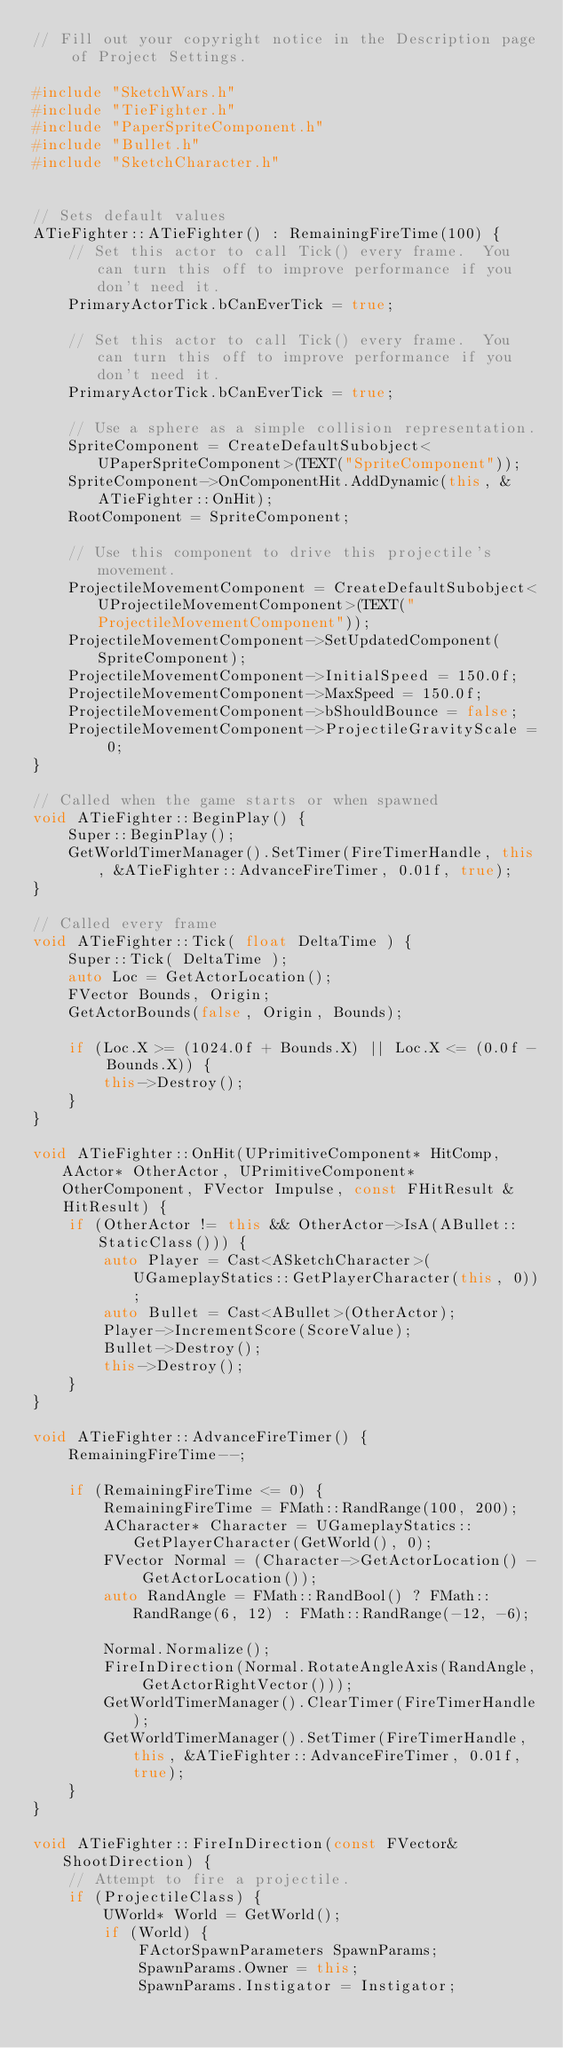<code> <loc_0><loc_0><loc_500><loc_500><_C++_>// Fill out your copyright notice in the Description page of Project Settings.

#include "SketchWars.h"
#include "TieFighter.h"
#include "PaperSpriteComponent.h"
#include "Bullet.h"
#include "SketchCharacter.h"


// Sets default values
ATieFighter::ATieFighter() : RemainingFireTime(100) {
 	// Set this actor to call Tick() every frame.  You can turn this off to improve performance if you don't need it.
	PrimaryActorTick.bCanEverTick = true;

	// Set this actor to call Tick() every frame.  You can turn this off to improve performance if you don't need it.
	PrimaryActorTick.bCanEverTick = true;

	// Use a sphere as a simple collision representation.
	SpriteComponent = CreateDefaultSubobject<UPaperSpriteComponent>(TEXT("SpriteComponent"));
	SpriteComponent->OnComponentHit.AddDynamic(this, &ATieFighter::OnHit);
	RootComponent = SpriteComponent;

	// Use this component to drive this projectile's movement.
	ProjectileMovementComponent = CreateDefaultSubobject<UProjectileMovementComponent>(TEXT("ProjectileMovementComponent"));
	ProjectileMovementComponent->SetUpdatedComponent(SpriteComponent);
	ProjectileMovementComponent->InitialSpeed = 150.0f;
	ProjectileMovementComponent->MaxSpeed = 150.0f;
	ProjectileMovementComponent->bShouldBounce = false;
	ProjectileMovementComponent->ProjectileGravityScale = 0;
}

// Called when the game starts or when spawned
void ATieFighter::BeginPlay() {
	Super::BeginPlay();
	GetWorldTimerManager().SetTimer(FireTimerHandle, this, &ATieFighter::AdvanceFireTimer, 0.01f, true);
}

// Called every frame
void ATieFighter::Tick( float DeltaTime ) {
	Super::Tick( DeltaTime );
	auto Loc = GetActorLocation();
	FVector Bounds, Origin;
	GetActorBounds(false, Origin, Bounds);

	if (Loc.X >= (1024.0f + Bounds.X) || Loc.X <= (0.0f - Bounds.X)) {
		this->Destroy();
	}
}

void ATieFighter::OnHit(UPrimitiveComponent* HitComp, AActor* OtherActor, UPrimitiveComponent* OtherComponent, FVector Impulse, const FHitResult & HitResult) {
	if (OtherActor != this && OtherActor->IsA(ABullet::StaticClass())) {
		auto Player = Cast<ASketchCharacter>(UGameplayStatics::GetPlayerCharacter(this, 0));
		auto Bullet = Cast<ABullet>(OtherActor);
		Player->IncrementScore(ScoreValue);
		Bullet->Destroy();
		this->Destroy();
	}
}

void ATieFighter::AdvanceFireTimer() {
	RemainingFireTime--;

	if (RemainingFireTime <= 0) {
		RemainingFireTime = FMath::RandRange(100, 200);
		ACharacter* Character = UGameplayStatics::GetPlayerCharacter(GetWorld(), 0);
		FVector Normal = (Character->GetActorLocation() - GetActorLocation());
		auto RandAngle = FMath::RandBool() ? FMath::RandRange(6, 12) : FMath::RandRange(-12, -6);

		Normal.Normalize();
		FireInDirection(Normal.RotateAngleAxis(RandAngle, GetActorRightVector()));
		GetWorldTimerManager().ClearTimer(FireTimerHandle);
		GetWorldTimerManager().SetTimer(FireTimerHandle, this, &ATieFighter::AdvanceFireTimer, 0.01f, true);
	}
}

void ATieFighter::FireInDirection(const FVector& ShootDirection) {
	// Attempt to fire a projectile.
	if (ProjectileClass) {
		UWorld* World = GetWorld();
		if (World) {
			FActorSpawnParameters SpawnParams;
			SpawnParams.Owner = this;
			SpawnParams.Instigator = Instigator;</code> 